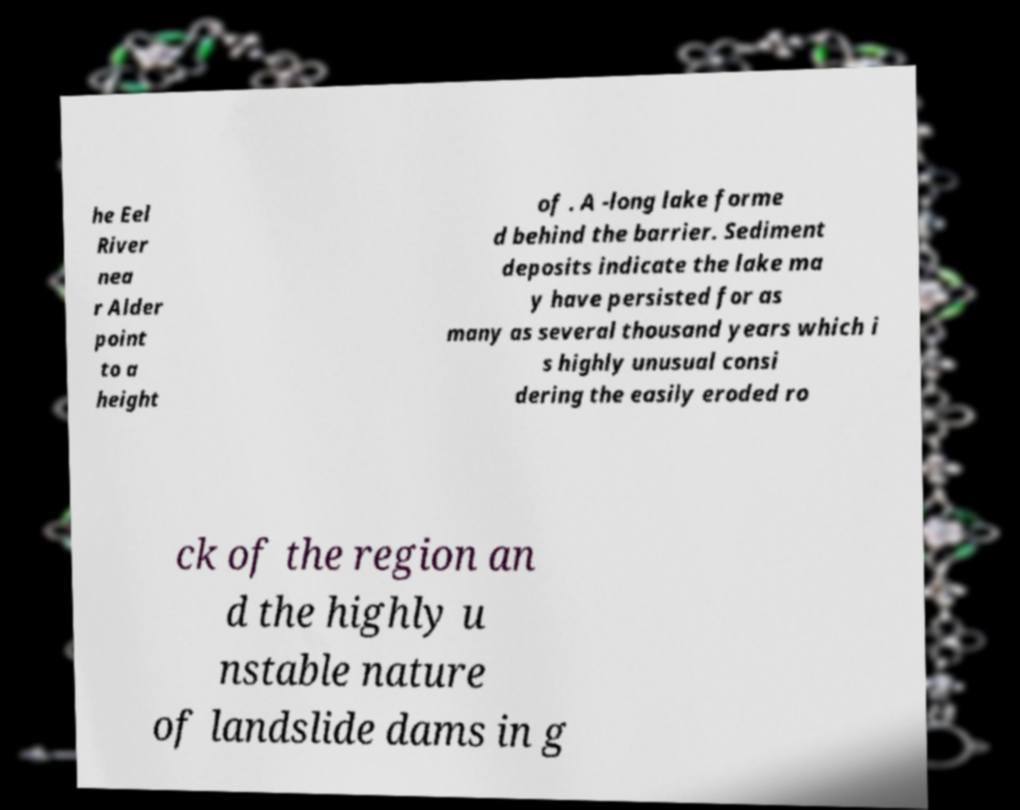Can you read and provide the text displayed in the image?This photo seems to have some interesting text. Can you extract and type it out for me? he Eel River nea r Alder point to a height of . A -long lake forme d behind the barrier. Sediment deposits indicate the lake ma y have persisted for as many as several thousand years which i s highly unusual consi dering the easily eroded ro ck of the region an d the highly u nstable nature of landslide dams in g 